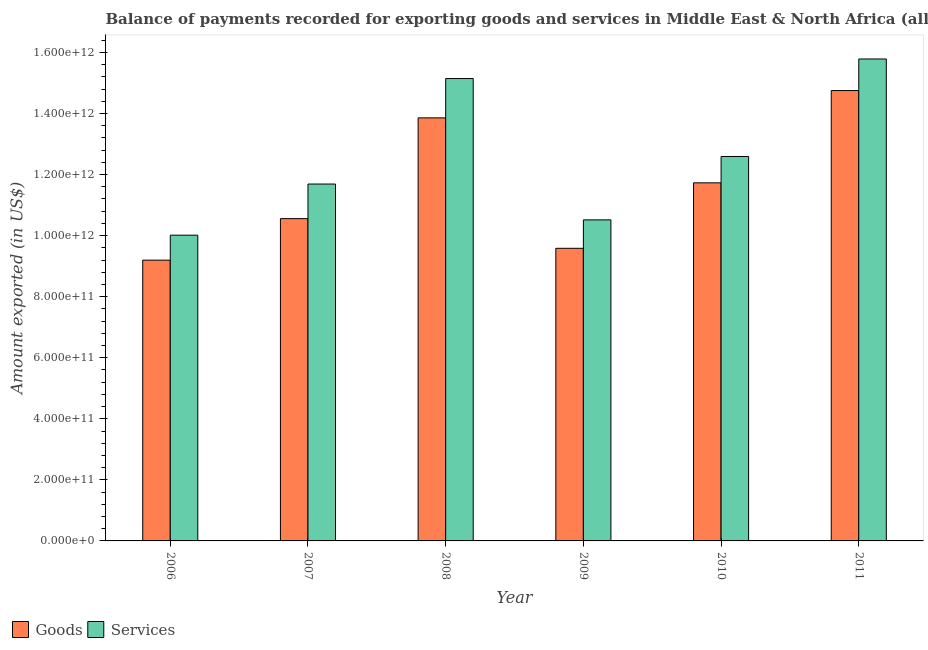Are the number of bars per tick equal to the number of legend labels?
Your answer should be compact. Yes. How many bars are there on the 5th tick from the left?
Offer a terse response. 2. How many bars are there on the 2nd tick from the right?
Offer a terse response. 2. What is the label of the 3rd group of bars from the left?
Offer a terse response. 2008. What is the amount of services exported in 2009?
Keep it short and to the point. 1.05e+12. Across all years, what is the maximum amount of services exported?
Ensure brevity in your answer.  1.58e+12. Across all years, what is the minimum amount of goods exported?
Provide a short and direct response. 9.20e+11. In which year was the amount of goods exported maximum?
Ensure brevity in your answer.  2011. In which year was the amount of services exported minimum?
Offer a terse response. 2006. What is the total amount of services exported in the graph?
Offer a terse response. 7.57e+12. What is the difference between the amount of goods exported in 2006 and that in 2007?
Your answer should be compact. -1.36e+11. What is the difference between the amount of services exported in 2006 and the amount of goods exported in 2009?
Give a very brief answer. -5.01e+1. What is the average amount of services exported per year?
Keep it short and to the point. 1.26e+12. In the year 2011, what is the difference between the amount of services exported and amount of goods exported?
Ensure brevity in your answer.  0. What is the ratio of the amount of goods exported in 2009 to that in 2011?
Your response must be concise. 0.65. What is the difference between the highest and the second highest amount of goods exported?
Offer a very short reply. 8.94e+1. What is the difference between the highest and the lowest amount of services exported?
Offer a very short reply. 5.77e+11. In how many years, is the amount of services exported greater than the average amount of services exported taken over all years?
Provide a short and direct response. 2. Is the sum of the amount of services exported in 2008 and 2009 greater than the maximum amount of goods exported across all years?
Your response must be concise. Yes. What does the 1st bar from the left in 2008 represents?
Offer a terse response. Goods. What does the 2nd bar from the right in 2008 represents?
Keep it short and to the point. Goods. Are all the bars in the graph horizontal?
Ensure brevity in your answer.  No. What is the difference between two consecutive major ticks on the Y-axis?
Your answer should be very brief. 2.00e+11. How many legend labels are there?
Offer a terse response. 2. How are the legend labels stacked?
Your response must be concise. Horizontal. What is the title of the graph?
Your response must be concise. Balance of payments recorded for exporting goods and services in Middle East & North Africa (all income levels). What is the label or title of the X-axis?
Provide a short and direct response. Year. What is the label or title of the Y-axis?
Keep it short and to the point. Amount exported (in US$). What is the Amount exported (in US$) in Goods in 2006?
Offer a terse response. 9.20e+11. What is the Amount exported (in US$) in Services in 2006?
Offer a terse response. 1.00e+12. What is the Amount exported (in US$) of Goods in 2007?
Keep it short and to the point. 1.06e+12. What is the Amount exported (in US$) in Services in 2007?
Your answer should be compact. 1.17e+12. What is the Amount exported (in US$) of Goods in 2008?
Make the answer very short. 1.39e+12. What is the Amount exported (in US$) of Services in 2008?
Make the answer very short. 1.51e+12. What is the Amount exported (in US$) of Goods in 2009?
Provide a short and direct response. 9.58e+11. What is the Amount exported (in US$) of Services in 2009?
Make the answer very short. 1.05e+12. What is the Amount exported (in US$) of Goods in 2010?
Provide a succinct answer. 1.17e+12. What is the Amount exported (in US$) of Services in 2010?
Offer a very short reply. 1.26e+12. What is the Amount exported (in US$) of Goods in 2011?
Provide a short and direct response. 1.48e+12. What is the Amount exported (in US$) of Services in 2011?
Ensure brevity in your answer.  1.58e+12. Across all years, what is the maximum Amount exported (in US$) in Goods?
Your answer should be compact. 1.48e+12. Across all years, what is the maximum Amount exported (in US$) of Services?
Your response must be concise. 1.58e+12. Across all years, what is the minimum Amount exported (in US$) of Goods?
Provide a short and direct response. 9.20e+11. Across all years, what is the minimum Amount exported (in US$) of Services?
Make the answer very short. 1.00e+12. What is the total Amount exported (in US$) of Goods in the graph?
Offer a terse response. 6.97e+12. What is the total Amount exported (in US$) of Services in the graph?
Your response must be concise. 7.57e+12. What is the difference between the Amount exported (in US$) of Goods in 2006 and that in 2007?
Provide a succinct answer. -1.36e+11. What is the difference between the Amount exported (in US$) in Services in 2006 and that in 2007?
Keep it short and to the point. -1.67e+11. What is the difference between the Amount exported (in US$) in Goods in 2006 and that in 2008?
Your response must be concise. -4.66e+11. What is the difference between the Amount exported (in US$) of Services in 2006 and that in 2008?
Your answer should be compact. -5.13e+11. What is the difference between the Amount exported (in US$) in Goods in 2006 and that in 2009?
Your answer should be very brief. -3.88e+1. What is the difference between the Amount exported (in US$) in Services in 2006 and that in 2009?
Provide a succinct answer. -5.01e+1. What is the difference between the Amount exported (in US$) of Goods in 2006 and that in 2010?
Keep it short and to the point. -2.53e+11. What is the difference between the Amount exported (in US$) in Services in 2006 and that in 2010?
Keep it short and to the point. -2.58e+11. What is the difference between the Amount exported (in US$) of Goods in 2006 and that in 2011?
Ensure brevity in your answer.  -5.55e+11. What is the difference between the Amount exported (in US$) of Services in 2006 and that in 2011?
Your answer should be very brief. -5.77e+11. What is the difference between the Amount exported (in US$) of Goods in 2007 and that in 2008?
Offer a very short reply. -3.30e+11. What is the difference between the Amount exported (in US$) of Services in 2007 and that in 2008?
Keep it short and to the point. -3.46e+11. What is the difference between the Amount exported (in US$) in Goods in 2007 and that in 2009?
Provide a short and direct response. 9.71e+1. What is the difference between the Amount exported (in US$) of Services in 2007 and that in 2009?
Your answer should be compact. 1.17e+11. What is the difference between the Amount exported (in US$) of Goods in 2007 and that in 2010?
Offer a terse response. -1.17e+11. What is the difference between the Amount exported (in US$) in Services in 2007 and that in 2010?
Give a very brief answer. -9.02e+1. What is the difference between the Amount exported (in US$) of Goods in 2007 and that in 2011?
Your response must be concise. -4.19e+11. What is the difference between the Amount exported (in US$) of Services in 2007 and that in 2011?
Your answer should be very brief. -4.10e+11. What is the difference between the Amount exported (in US$) of Goods in 2008 and that in 2009?
Make the answer very short. 4.27e+11. What is the difference between the Amount exported (in US$) in Services in 2008 and that in 2009?
Offer a very short reply. 4.63e+11. What is the difference between the Amount exported (in US$) in Goods in 2008 and that in 2010?
Provide a succinct answer. 2.13e+11. What is the difference between the Amount exported (in US$) of Services in 2008 and that in 2010?
Your answer should be compact. 2.55e+11. What is the difference between the Amount exported (in US$) in Goods in 2008 and that in 2011?
Make the answer very short. -8.94e+1. What is the difference between the Amount exported (in US$) in Services in 2008 and that in 2011?
Give a very brief answer. -6.41e+1. What is the difference between the Amount exported (in US$) in Goods in 2009 and that in 2010?
Give a very brief answer. -2.14e+11. What is the difference between the Amount exported (in US$) of Services in 2009 and that in 2010?
Keep it short and to the point. -2.08e+11. What is the difference between the Amount exported (in US$) in Goods in 2009 and that in 2011?
Your answer should be very brief. -5.17e+11. What is the difference between the Amount exported (in US$) of Services in 2009 and that in 2011?
Offer a terse response. -5.27e+11. What is the difference between the Amount exported (in US$) of Goods in 2010 and that in 2011?
Your response must be concise. -3.02e+11. What is the difference between the Amount exported (in US$) of Services in 2010 and that in 2011?
Ensure brevity in your answer.  -3.19e+11. What is the difference between the Amount exported (in US$) in Goods in 2006 and the Amount exported (in US$) in Services in 2007?
Ensure brevity in your answer.  -2.49e+11. What is the difference between the Amount exported (in US$) in Goods in 2006 and the Amount exported (in US$) in Services in 2008?
Ensure brevity in your answer.  -5.95e+11. What is the difference between the Amount exported (in US$) in Goods in 2006 and the Amount exported (in US$) in Services in 2009?
Provide a short and direct response. -1.32e+11. What is the difference between the Amount exported (in US$) of Goods in 2006 and the Amount exported (in US$) of Services in 2010?
Give a very brief answer. -3.39e+11. What is the difference between the Amount exported (in US$) of Goods in 2006 and the Amount exported (in US$) of Services in 2011?
Make the answer very short. -6.59e+11. What is the difference between the Amount exported (in US$) of Goods in 2007 and the Amount exported (in US$) of Services in 2008?
Your response must be concise. -4.59e+11. What is the difference between the Amount exported (in US$) in Goods in 2007 and the Amount exported (in US$) in Services in 2009?
Ensure brevity in your answer.  4.05e+09. What is the difference between the Amount exported (in US$) of Goods in 2007 and the Amount exported (in US$) of Services in 2010?
Offer a terse response. -2.04e+11. What is the difference between the Amount exported (in US$) of Goods in 2007 and the Amount exported (in US$) of Services in 2011?
Your answer should be compact. -5.23e+11. What is the difference between the Amount exported (in US$) of Goods in 2008 and the Amount exported (in US$) of Services in 2009?
Ensure brevity in your answer.  3.34e+11. What is the difference between the Amount exported (in US$) of Goods in 2008 and the Amount exported (in US$) of Services in 2010?
Offer a very short reply. 1.27e+11. What is the difference between the Amount exported (in US$) in Goods in 2008 and the Amount exported (in US$) in Services in 2011?
Your answer should be very brief. -1.93e+11. What is the difference between the Amount exported (in US$) of Goods in 2009 and the Amount exported (in US$) of Services in 2010?
Your answer should be very brief. -3.01e+11. What is the difference between the Amount exported (in US$) in Goods in 2009 and the Amount exported (in US$) in Services in 2011?
Offer a very short reply. -6.20e+11. What is the difference between the Amount exported (in US$) of Goods in 2010 and the Amount exported (in US$) of Services in 2011?
Your answer should be compact. -4.06e+11. What is the average Amount exported (in US$) of Goods per year?
Provide a short and direct response. 1.16e+12. What is the average Amount exported (in US$) of Services per year?
Provide a succinct answer. 1.26e+12. In the year 2006, what is the difference between the Amount exported (in US$) of Goods and Amount exported (in US$) of Services?
Give a very brief answer. -8.18e+1. In the year 2007, what is the difference between the Amount exported (in US$) in Goods and Amount exported (in US$) in Services?
Offer a very short reply. -1.13e+11. In the year 2008, what is the difference between the Amount exported (in US$) in Goods and Amount exported (in US$) in Services?
Give a very brief answer. -1.29e+11. In the year 2009, what is the difference between the Amount exported (in US$) in Goods and Amount exported (in US$) in Services?
Ensure brevity in your answer.  -9.31e+1. In the year 2010, what is the difference between the Amount exported (in US$) of Goods and Amount exported (in US$) of Services?
Give a very brief answer. -8.63e+1. In the year 2011, what is the difference between the Amount exported (in US$) of Goods and Amount exported (in US$) of Services?
Offer a very short reply. -1.03e+11. What is the ratio of the Amount exported (in US$) of Goods in 2006 to that in 2007?
Give a very brief answer. 0.87. What is the ratio of the Amount exported (in US$) in Services in 2006 to that in 2007?
Give a very brief answer. 0.86. What is the ratio of the Amount exported (in US$) of Goods in 2006 to that in 2008?
Give a very brief answer. 0.66. What is the ratio of the Amount exported (in US$) in Services in 2006 to that in 2008?
Keep it short and to the point. 0.66. What is the ratio of the Amount exported (in US$) of Goods in 2006 to that in 2009?
Give a very brief answer. 0.96. What is the ratio of the Amount exported (in US$) in Services in 2006 to that in 2009?
Ensure brevity in your answer.  0.95. What is the ratio of the Amount exported (in US$) in Goods in 2006 to that in 2010?
Make the answer very short. 0.78. What is the ratio of the Amount exported (in US$) in Services in 2006 to that in 2010?
Offer a very short reply. 0.8. What is the ratio of the Amount exported (in US$) in Goods in 2006 to that in 2011?
Offer a very short reply. 0.62. What is the ratio of the Amount exported (in US$) in Services in 2006 to that in 2011?
Your answer should be very brief. 0.63. What is the ratio of the Amount exported (in US$) in Goods in 2007 to that in 2008?
Give a very brief answer. 0.76. What is the ratio of the Amount exported (in US$) of Services in 2007 to that in 2008?
Keep it short and to the point. 0.77. What is the ratio of the Amount exported (in US$) in Goods in 2007 to that in 2009?
Provide a succinct answer. 1.1. What is the ratio of the Amount exported (in US$) of Services in 2007 to that in 2009?
Offer a very short reply. 1.11. What is the ratio of the Amount exported (in US$) in Services in 2007 to that in 2010?
Keep it short and to the point. 0.93. What is the ratio of the Amount exported (in US$) in Goods in 2007 to that in 2011?
Ensure brevity in your answer.  0.72. What is the ratio of the Amount exported (in US$) in Services in 2007 to that in 2011?
Your answer should be very brief. 0.74. What is the ratio of the Amount exported (in US$) of Goods in 2008 to that in 2009?
Provide a short and direct response. 1.45. What is the ratio of the Amount exported (in US$) of Services in 2008 to that in 2009?
Keep it short and to the point. 1.44. What is the ratio of the Amount exported (in US$) of Goods in 2008 to that in 2010?
Your response must be concise. 1.18. What is the ratio of the Amount exported (in US$) of Services in 2008 to that in 2010?
Keep it short and to the point. 1.2. What is the ratio of the Amount exported (in US$) in Goods in 2008 to that in 2011?
Provide a succinct answer. 0.94. What is the ratio of the Amount exported (in US$) in Services in 2008 to that in 2011?
Your answer should be compact. 0.96. What is the ratio of the Amount exported (in US$) in Goods in 2009 to that in 2010?
Your answer should be very brief. 0.82. What is the ratio of the Amount exported (in US$) of Services in 2009 to that in 2010?
Make the answer very short. 0.84. What is the ratio of the Amount exported (in US$) of Goods in 2009 to that in 2011?
Your answer should be compact. 0.65. What is the ratio of the Amount exported (in US$) in Services in 2009 to that in 2011?
Provide a short and direct response. 0.67. What is the ratio of the Amount exported (in US$) of Goods in 2010 to that in 2011?
Offer a terse response. 0.8. What is the ratio of the Amount exported (in US$) in Services in 2010 to that in 2011?
Your answer should be very brief. 0.8. What is the difference between the highest and the second highest Amount exported (in US$) in Goods?
Keep it short and to the point. 8.94e+1. What is the difference between the highest and the second highest Amount exported (in US$) in Services?
Your answer should be compact. 6.41e+1. What is the difference between the highest and the lowest Amount exported (in US$) in Goods?
Ensure brevity in your answer.  5.55e+11. What is the difference between the highest and the lowest Amount exported (in US$) of Services?
Ensure brevity in your answer.  5.77e+11. 